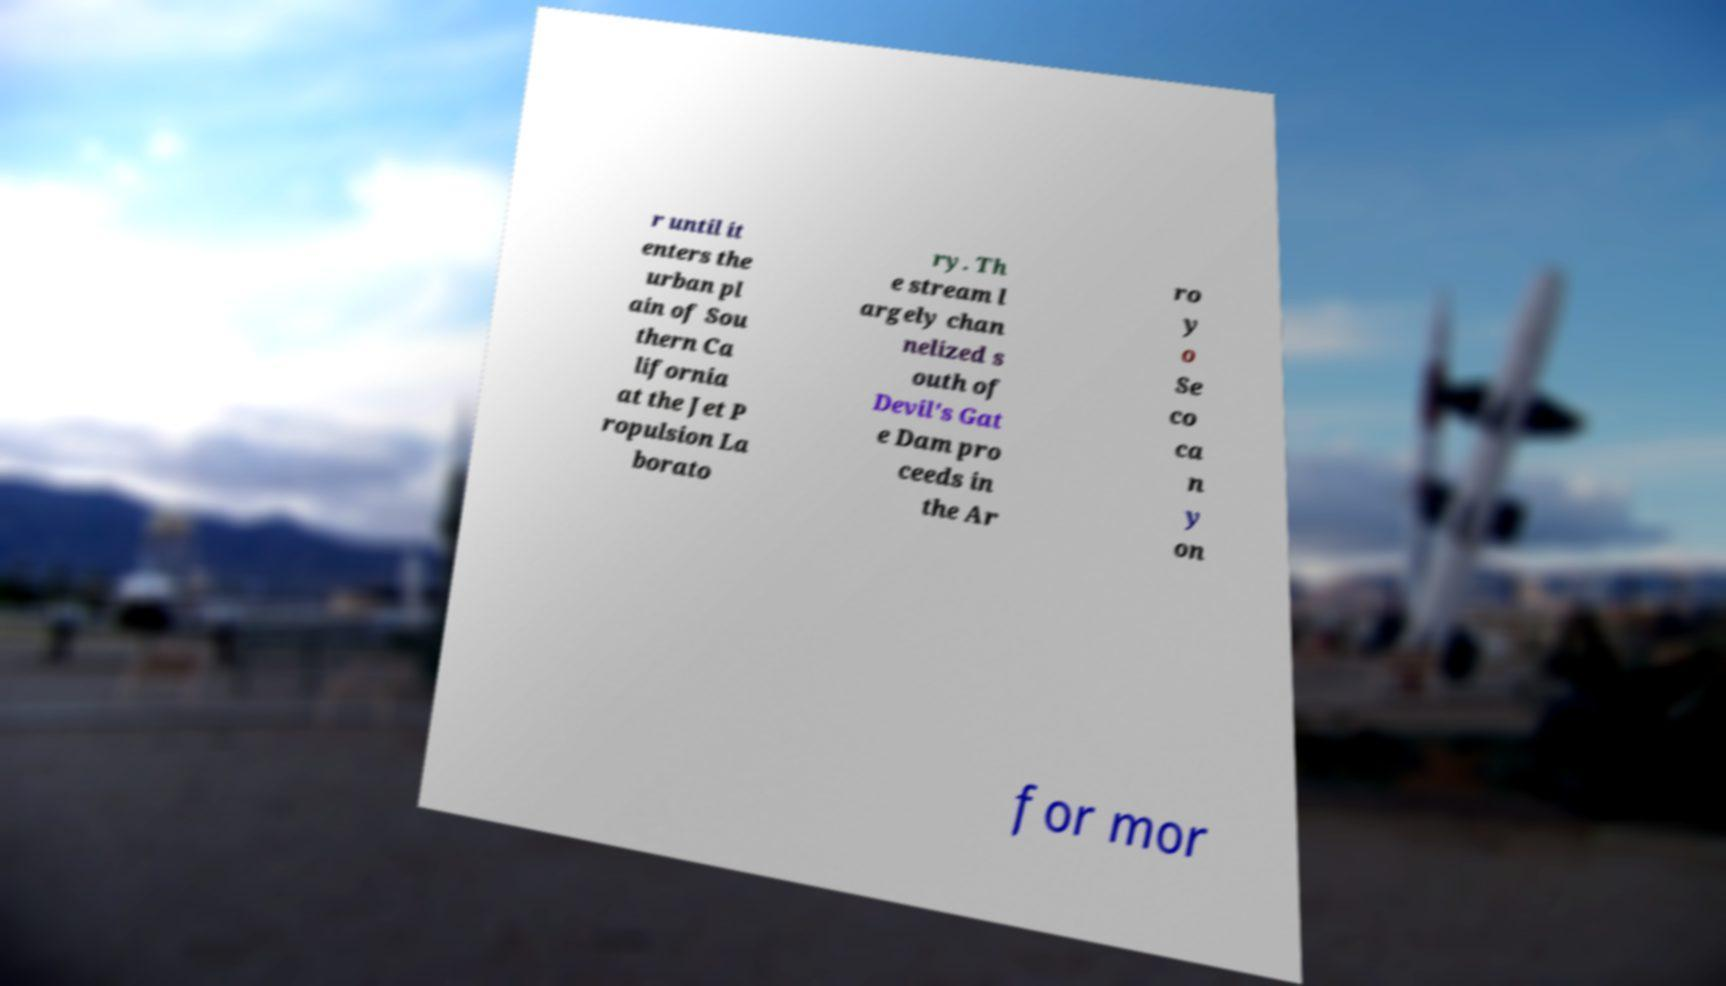What messages or text are displayed in this image? I need them in a readable, typed format. r until it enters the urban pl ain of Sou thern Ca lifornia at the Jet P ropulsion La borato ry. Th e stream l argely chan nelized s outh of Devil's Gat e Dam pro ceeds in the Ar ro y o Se co ca n y on for mor 